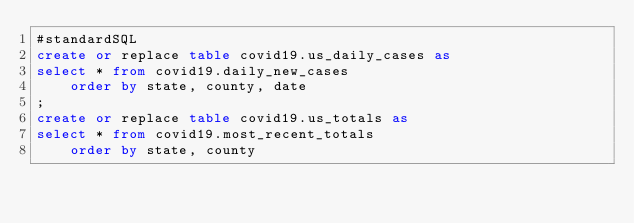<code> <loc_0><loc_0><loc_500><loc_500><_SQL_>#standardSQL
create or replace table covid19.us_daily_cases as
select * from covid19.daily_new_cases
	order by state, county, date
;
create or replace table covid19.us_totals as
select * from covid19.most_recent_totals
	order by state, county
</code> 